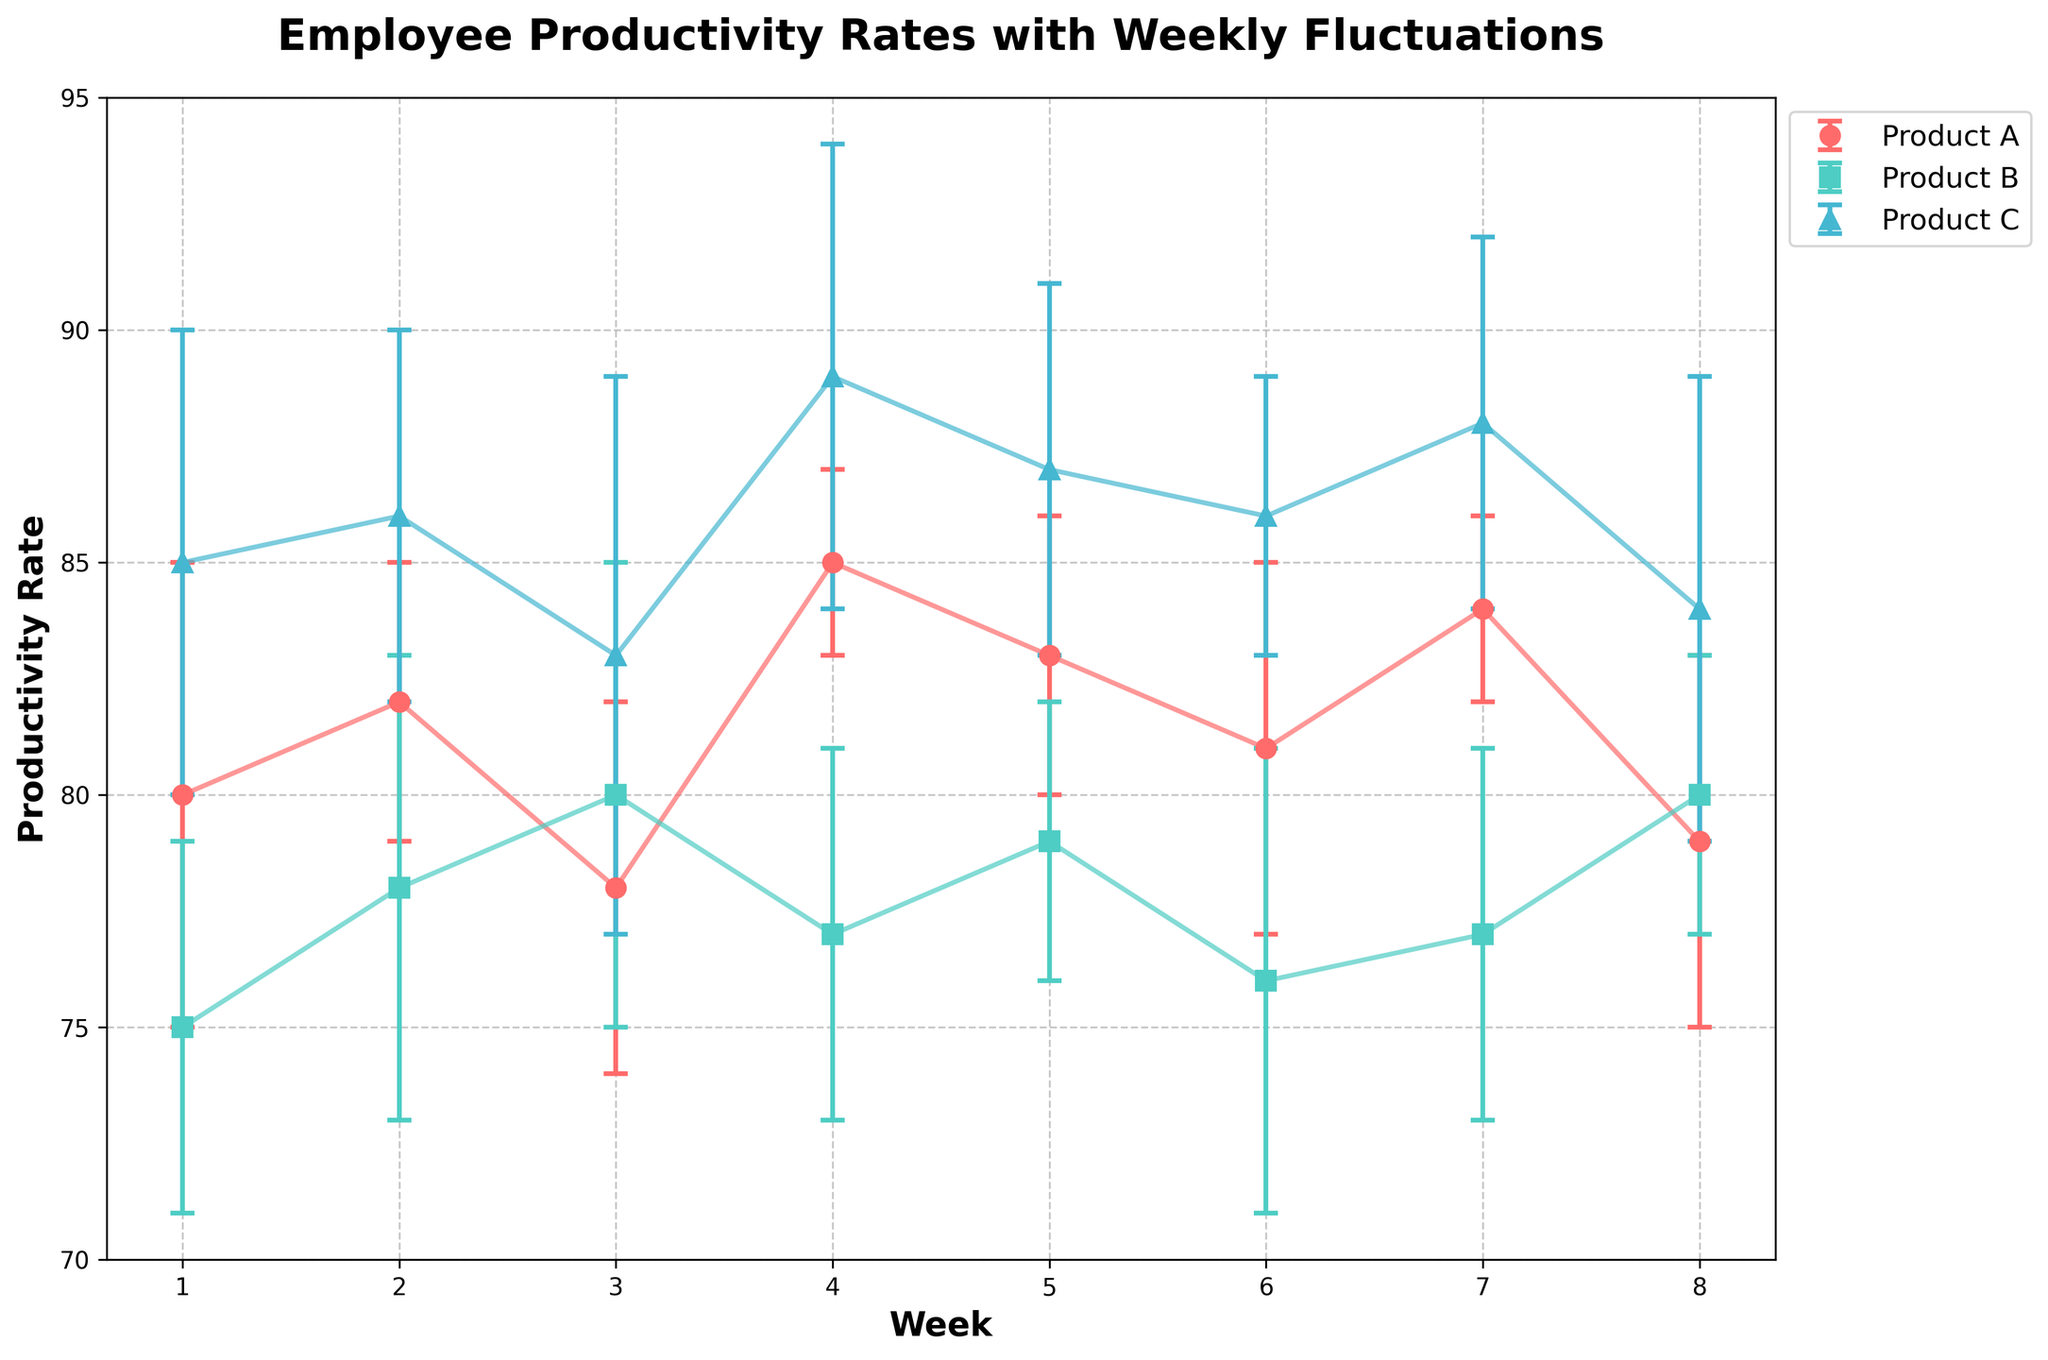What is the overall title of the figure? The overall title is displayed at the top of the figure and reads 'Employee Productivity Rates with Weekly Fluctuations'.
Answer: Employee Productivity Rates with Weekly Fluctuations What variable is plotted on the x-axis? The label for the x-axis can be found beneath the horizontal axis at the bottom of the plot, and it is 'Week'.
Answer: Week What variable is plotted on the y-axis? The label for the y-axis appears to the left of the vertical axis on the plot, and it is 'Productivity Rate'.
Answer: Productivity Rate How many weeks of data does the plot show? The x-axis includes labeled ticks representing each week. Counting these ticks reveals there are 8 weeks.
Answer: 8 weeks Which product has the highest mean productivity rate at week 4? By looking at the mean productivity rates at week 4 for all products, Product C has the highest value as indicated by the tallest point.
Answer: Product C What is the mean productivity rate for Product A at week 5? By locating the point for Product A at week 5 along the x-axis and reading its value on the y-axis, the mean productivity rate is seen to be 83.
Answer: 83 What is the approximate error range for Product B at week 7? The error bars represent the range of uncertainty around the mean, which for Product B at week 7 is from 77 - 4 to 77 + 4, giving a range of 73 to 81.
Answer: 73 to 81 Which product shows the greatest fluctuation in mean productivity rates over the 8 weeks? The fluctuation in mean productivity rates can be observed by the variability of the lines for each product. Product C shows the highest variability with values spanning the widest range.
Answer: Product C How does the mean productivity rate of Product B change from week 2 to week 3? By comparing the points for Product B in weeks 2 and 3, we can see the mean productivity rate increases from 78 to 80.
Answer: Increases What week does Product A show its lowest mean productivity rate? By examining the points for Product A across all weeks, the lowest mean productivity rate is at week 3 with a value of 78.
Answer: Week 3 